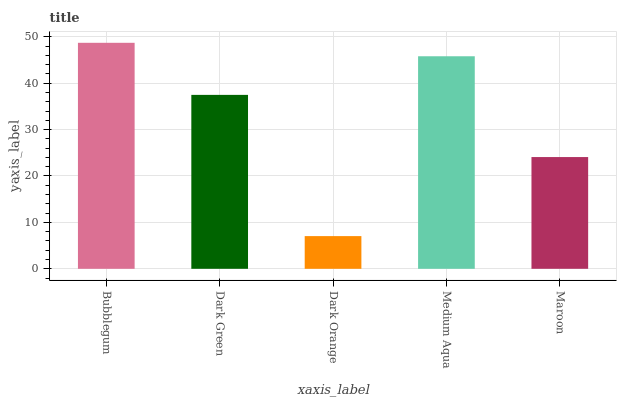Is Dark Orange the minimum?
Answer yes or no. Yes. Is Bubblegum the maximum?
Answer yes or no. Yes. Is Dark Green the minimum?
Answer yes or no. No. Is Dark Green the maximum?
Answer yes or no. No. Is Bubblegum greater than Dark Green?
Answer yes or no. Yes. Is Dark Green less than Bubblegum?
Answer yes or no. Yes. Is Dark Green greater than Bubblegum?
Answer yes or no. No. Is Bubblegum less than Dark Green?
Answer yes or no. No. Is Dark Green the high median?
Answer yes or no. Yes. Is Dark Green the low median?
Answer yes or no. Yes. Is Bubblegum the high median?
Answer yes or no. No. Is Medium Aqua the low median?
Answer yes or no. No. 